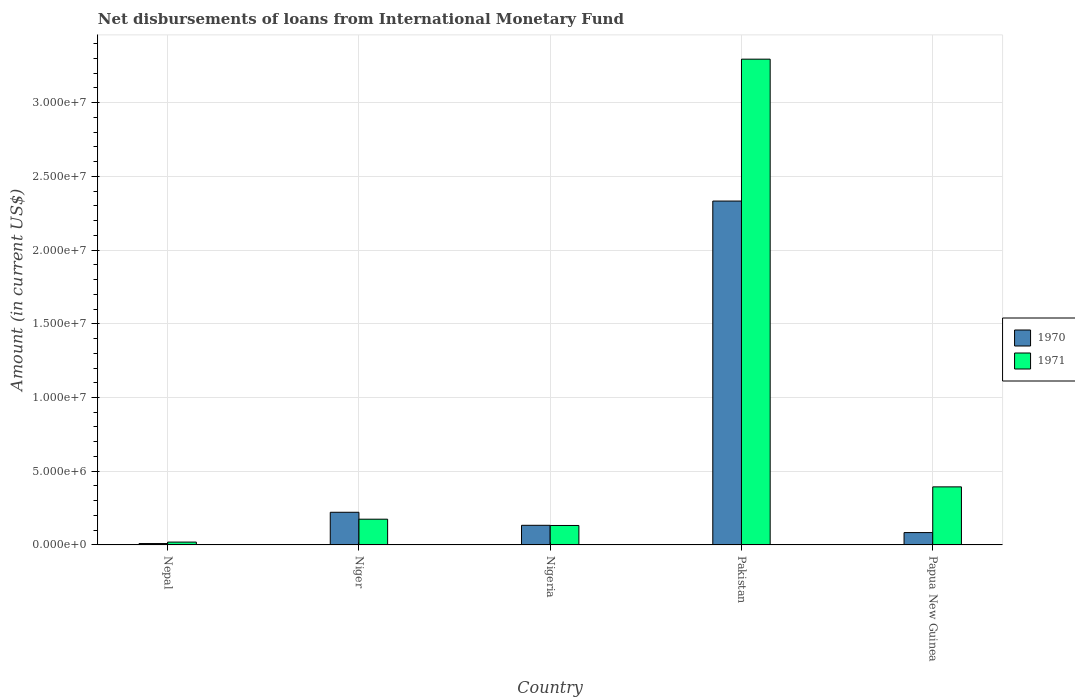Are the number of bars on each tick of the X-axis equal?
Give a very brief answer. Yes. How many bars are there on the 2nd tick from the left?
Give a very brief answer. 2. What is the label of the 5th group of bars from the left?
Provide a short and direct response. Papua New Guinea. What is the amount of loans disbursed in 1971 in Nepal?
Give a very brief answer. 1.93e+05. Across all countries, what is the maximum amount of loans disbursed in 1970?
Ensure brevity in your answer.  2.33e+07. Across all countries, what is the minimum amount of loans disbursed in 1970?
Provide a succinct answer. 9.30e+04. In which country was the amount of loans disbursed in 1970 minimum?
Give a very brief answer. Nepal. What is the total amount of loans disbursed in 1970 in the graph?
Provide a short and direct response. 2.78e+07. What is the difference between the amount of loans disbursed in 1970 in Niger and that in Pakistan?
Your answer should be compact. -2.11e+07. What is the difference between the amount of loans disbursed in 1970 in Niger and the amount of loans disbursed in 1971 in Nigeria?
Keep it short and to the point. 8.95e+05. What is the average amount of loans disbursed in 1971 per country?
Offer a very short reply. 8.03e+06. What is the difference between the amount of loans disbursed of/in 1971 and amount of loans disbursed of/in 1970 in Papua New Guinea?
Give a very brief answer. 3.10e+06. In how many countries, is the amount of loans disbursed in 1971 greater than 18000000 US$?
Your response must be concise. 1. What is the ratio of the amount of loans disbursed in 1970 in Nepal to that in Nigeria?
Your answer should be compact. 0.07. Is the difference between the amount of loans disbursed in 1971 in Pakistan and Papua New Guinea greater than the difference between the amount of loans disbursed in 1970 in Pakistan and Papua New Guinea?
Give a very brief answer. Yes. What is the difference between the highest and the second highest amount of loans disbursed in 1971?
Give a very brief answer. 3.12e+07. What is the difference between the highest and the lowest amount of loans disbursed in 1970?
Give a very brief answer. 2.32e+07. Is the sum of the amount of loans disbursed in 1970 in Nigeria and Papua New Guinea greater than the maximum amount of loans disbursed in 1971 across all countries?
Offer a very short reply. No. What does the 2nd bar from the left in Papua New Guinea represents?
Your answer should be compact. 1971. What does the 2nd bar from the right in Nepal represents?
Provide a short and direct response. 1970. How many bars are there?
Keep it short and to the point. 10. How many countries are there in the graph?
Your response must be concise. 5. Does the graph contain any zero values?
Provide a short and direct response. No. Does the graph contain grids?
Provide a short and direct response. Yes. Where does the legend appear in the graph?
Ensure brevity in your answer.  Center right. What is the title of the graph?
Offer a very short reply. Net disbursements of loans from International Monetary Fund. What is the label or title of the Y-axis?
Your response must be concise. Amount (in current US$). What is the Amount (in current US$) in 1970 in Nepal?
Keep it short and to the point. 9.30e+04. What is the Amount (in current US$) in 1971 in Nepal?
Keep it short and to the point. 1.93e+05. What is the Amount (in current US$) in 1970 in Niger?
Make the answer very short. 2.22e+06. What is the Amount (in current US$) of 1971 in Niger?
Your answer should be very brief. 1.75e+06. What is the Amount (in current US$) in 1970 in Nigeria?
Your answer should be compact. 1.33e+06. What is the Amount (in current US$) of 1971 in Nigeria?
Ensure brevity in your answer.  1.32e+06. What is the Amount (in current US$) in 1970 in Pakistan?
Provide a short and direct response. 2.33e+07. What is the Amount (in current US$) of 1971 in Pakistan?
Keep it short and to the point. 3.30e+07. What is the Amount (in current US$) of 1970 in Papua New Guinea?
Ensure brevity in your answer.  8.37e+05. What is the Amount (in current US$) in 1971 in Papua New Guinea?
Make the answer very short. 3.94e+06. Across all countries, what is the maximum Amount (in current US$) in 1970?
Ensure brevity in your answer.  2.33e+07. Across all countries, what is the maximum Amount (in current US$) in 1971?
Provide a succinct answer. 3.30e+07. Across all countries, what is the minimum Amount (in current US$) in 1970?
Offer a terse response. 9.30e+04. Across all countries, what is the minimum Amount (in current US$) of 1971?
Keep it short and to the point. 1.93e+05. What is the total Amount (in current US$) of 1970 in the graph?
Your answer should be very brief. 2.78e+07. What is the total Amount (in current US$) in 1971 in the graph?
Offer a very short reply. 4.02e+07. What is the difference between the Amount (in current US$) of 1970 in Nepal and that in Niger?
Offer a very short reply. -2.12e+06. What is the difference between the Amount (in current US$) of 1971 in Nepal and that in Niger?
Keep it short and to the point. -1.55e+06. What is the difference between the Amount (in current US$) of 1970 in Nepal and that in Nigeria?
Provide a succinct answer. -1.24e+06. What is the difference between the Amount (in current US$) in 1971 in Nepal and that in Nigeria?
Offer a terse response. -1.13e+06. What is the difference between the Amount (in current US$) of 1970 in Nepal and that in Pakistan?
Offer a terse response. -2.32e+07. What is the difference between the Amount (in current US$) in 1971 in Nepal and that in Pakistan?
Ensure brevity in your answer.  -3.28e+07. What is the difference between the Amount (in current US$) of 1970 in Nepal and that in Papua New Guinea?
Give a very brief answer. -7.44e+05. What is the difference between the Amount (in current US$) of 1971 in Nepal and that in Papua New Guinea?
Your response must be concise. -3.75e+06. What is the difference between the Amount (in current US$) of 1970 in Niger and that in Nigeria?
Make the answer very short. 8.84e+05. What is the difference between the Amount (in current US$) in 1971 in Niger and that in Nigeria?
Your answer should be very brief. 4.26e+05. What is the difference between the Amount (in current US$) in 1970 in Niger and that in Pakistan?
Give a very brief answer. -2.11e+07. What is the difference between the Amount (in current US$) in 1971 in Niger and that in Pakistan?
Provide a succinct answer. -3.12e+07. What is the difference between the Amount (in current US$) in 1970 in Niger and that in Papua New Guinea?
Offer a very short reply. 1.38e+06. What is the difference between the Amount (in current US$) of 1971 in Niger and that in Papua New Guinea?
Offer a very short reply. -2.19e+06. What is the difference between the Amount (in current US$) in 1970 in Nigeria and that in Pakistan?
Provide a succinct answer. -2.20e+07. What is the difference between the Amount (in current US$) in 1971 in Nigeria and that in Pakistan?
Make the answer very short. -3.16e+07. What is the difference between the Amount (in current US$) of 1970 in Nigeria and that in Papua New Guinea?
Your answer should be compact. 4.94e+05. What is the difference between the Amount (in current US$) of 1971 in Nigeria and that in Papua New Guinea?
Keep it short and to the point. -2.62e+06. What is the difference between the Amount (in current US$) of 1970 in Pakistan and that in Papua New Guinea?
Offer a terse response. 2.25e+07. What is the difference between the Amount (in current US$) of 1971 in Pakistan and that in Papua New Guinea?
Offer a very short reply. 2.90e+07. What is the difference between the Amount (in current US$) of 1970 in Nepal and the Amount (in current US$) of 1971 in Niger?
Ensure brevity in your answer.  -1.65e+06. What is the difference between the Amount (in current US$) of 1970 in Nepal and the Amount (in current US$) of 1971 in Nigeria?
Your answer should be very brief. -1.23e+06. What is the difference between the Amount (in current US$) in 1970 in Nepal and the Amount (in current US$) in 1971 in Pakistan?
Give a very brief answer. -3.29e+07. What is the difference between the Amount (in current US$) in 1970 in Nepal and the Amount (in current US$) in 1971 in Papua New Guinea?
Give a very brief answer. -3.85e+06. What is the difference between the Amount (in current US$) in 1970 in Niger and the Amount (in current US$) in 1971 in Nigeria?
Ensure brevity in your answer.  8.95e+05. What is the difference between the Amount (in current US$) of 1970 in Niger and the Amount (in current US$) of 1971 in Pakistan?
Your answer should be very brief. -3.07e+07. What is the difference between the Amount (in current US$) of 1970 in Niger and the Amount (in current US$) of 1971 in Papua New Guinea?
Your answer should be compact. -1.72e+06. What is the difference between the Amount (in current US$) of 1970 in Nigeria and the Amount (in current US$) of 1971 in Pakistan?
Your response must be concise. -3.16e+07. What is the difference between the Amount (in current US$) of 1970 in Nigeria and the Amount (in current US$) of 1971 in Papua New Guinea?
Give a very brief answer. -2.61e+06. What is the difference between the Amount (in current US$) in 1970 in Pakistan and the Amount (in current US$) in 1971 in Papua New Guinea?
Provide a succinct answer. 1.94e+07. What is the average Amount (in current US$) of 1970 per country?
Give a very brief answer. 5.56e+06. What is the average Amount (in current US$) of 1971 per country?
Your answer should be very brief. 8.03e+06. What is the difference between the Amount (in current US$) in 1970 and Amount (in current US$) in 1971 in Niger?
Ensure brevity in your answer.  4.69e+05. What is the difference between the Amount (in current US$) of 1970 and Amount (in current US$) of 1971 in Nigeria?
Provide a short and direct response. 1.10e+04. What is the difference between the Amount (in current US$) of 1970 and Amount (in current US$) of 1971 in Pakistan?
Your answer should be very brief. -9.62e+06. What is the difference between the Amount (in current US$) of 1970 and Amount (in current US$) of 1971 in Papua New Guinea?
Your answer should be very brief. -3.10e+06. What is the ratio of the Amount (in current US$) of 1970 in Nepal to that in Niger?
Provide a succinct answer. 0.04. What is the ratio of the Amount (in current US$) in 1971 in Nepal to that in Niger?
Give a very brief answer. 0.11. What is the ratio of the Amount (in current US$) in 1970 in Nepal to that in Nigeria?
Your response must be concise. 0.07. What is the ratio of the Amount (in current US$) in 1971 in Nepal to that in Nigeria?
Make the answer very short. 0.15. What is the ratio of the Amount (in current US$) in 1970 in Nepal to that in Pakistan?
Make the answer very short. 0. What is the ratio of the Amount (in current US$) in 1971 in Nepal to that in Pakistan?
Provide a succinct answer. 0.01. What is the ratio of the Amount (in current US$) of 1970 in Nepal to that in Papua New Guinea?
Give a very brief answer. 0.11. What is the ratio of the Amount (in current US$) of 1971 in Nepal to that in Papua New Guinea?
Offer a terse response. 0.05. What is the ratio of the Amount (in current US$) of 1970 in Niger to that in Nigeria?
Your answer should be compact. 1.66. What is the ratio of the Amount (in current US$) of 1971 in Niger to that in Nigeria?
Make the answer very short. 1.32. What is the ratio of the Amount (in current US$) in 1970 in Niger to that in Pakistan?
Give a very brief answer. 0.1. What is the ratio of the Amount (in current US$) in 1971 in Niger to that in Pakistan?
Offer a very short reply. 0.05. What is the ratio of the Amount (in current US$) in 1970 in Niger to that in Papua New Guinea?
Your response must be concise. 2.65. What is the ratio of the Amount (in current US$) in 1971 in Niger to that in Papua New Guinea?
Your answer should be very brief. 0.44. What is the ratio of the Amount (in current US$) in 1970 in Nigeria to that in Pakistan?
Your answer should be compact. 0.06. What is the ratio of the Amount (in current US$) in 1971 in Nigeria to that in Pakistan?
Your response must be concise. 0.04. What is the ratio of the Amount (in current US$) in 1970 in Nigeria to that in Papua New Guinea?
Offer a very short reply. 1.59. What is the ratio of the Amount (in current US$) in 1971 in Nigeria to that in Papua New Guinea?
Make the answer very short. 0.34. What is the ratio of the Amount (in current US$) of 1970 in Pakistan to that in Papua New Guinea?
Provide a succinct answer. 27.87. What is the ratio of the Amount (in current US$) in 1971 in Pakistan to that in Papua New Guinea?
Make the answer very short. 8.37. What is the difference between the highest and the second highest Amount (in current US$) in 1970?
Provide a short and direct response. 2.11e+07. What is the difference between the highest and the second highest Amount (in current US$) of 1971?
Offer a terse response. 2.90e+07. What is the difference between the highest and the lowest Amount (in current US$) of 1970?
Make the answer very short. 2.32e+07. What is the difference between the highest and the lowest Amount (in current US$) of 1971?
Ensure brevity in your answer.  3.28e+07. 